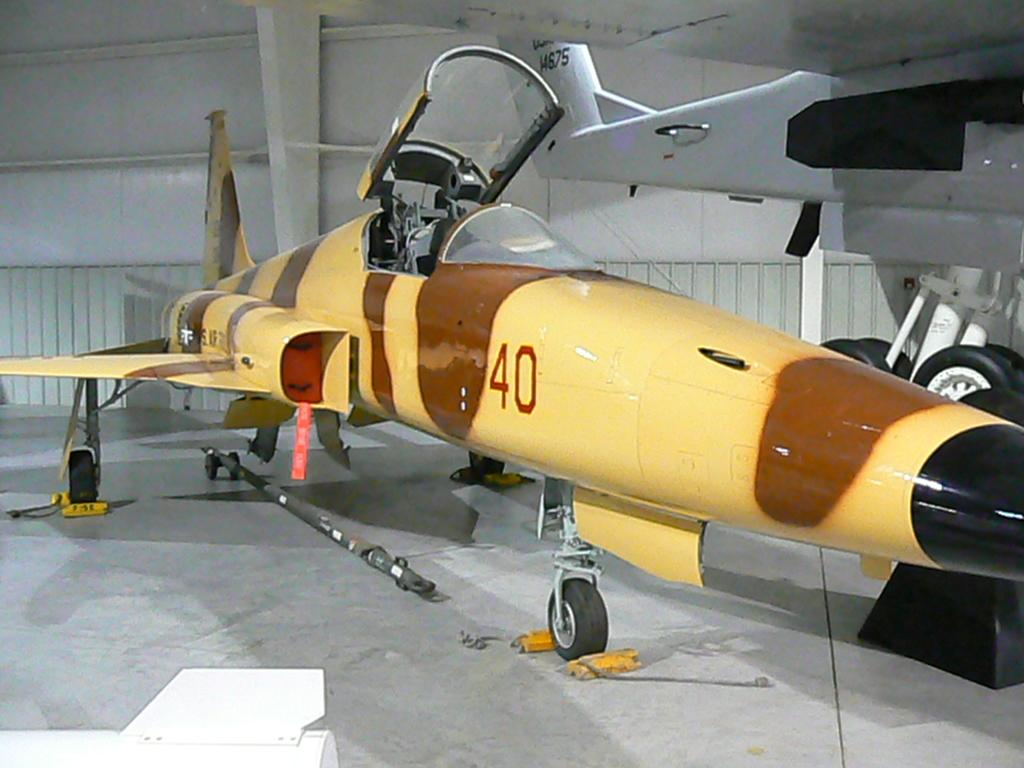<image>
Present a compact description of the photo's key features. A shiny fighter jet sits in a hangar with the number 40 painted on the side. 